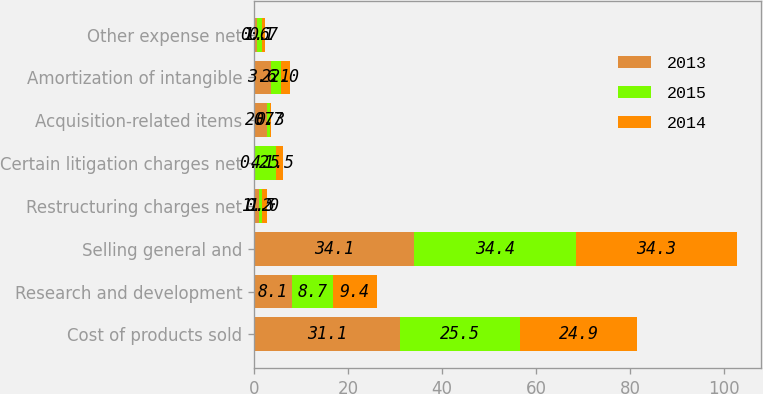Convert chart. <chart><loc_0><loc_0><loc_500><loc_500><stacked_bar_chart><ecel><fcel>Cost of products sold<fcel>Research and development<fcel>Selling general and<fcel>Restructuring charges net<fcel>Certain litigation charges net<fcel>Acquisition-related items<fcel>Amortization of intangible<fcel>Other expense net<nl><fcel>2013<fcel>31.1<fcel>8.1<fcel>34.1<fcel>1.2<fcel>0.2<fcel>2.7<fcel>3.6<fcel>0.6<nl><fcel>2015<fcel>25.5<fcel>8.7<fcel>34.4<fcel>0.5<fcel>4.5<fcel>0.7<fcel>2.1<fcel>1.1<nl><fcel>2014<fcel>24.9<fcel>9.4<fcel>34.3<fcel>1<fcel>1.5<fcel>0.3<fcel>2<fcel>0.7<nl></chart> 